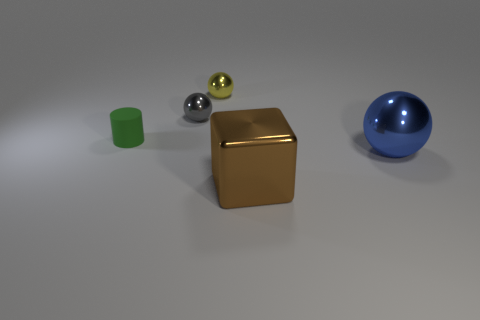What number of tiny cylinders are right of the rubber cylinder?
Provide a short and direct response. 0. There is a ball that is both in front of the yellow shiny thing and behind the blue metal sphere; what is it made of?
Ensure brevity in your answer.  Metal. What number of other blocks have the same size as the block?
Give a very brief answer. 0. There is a small object on the left side of the tiny gray ball that is on the left side of the large brown cube; what color is it?
Give a very brief answer. Green. Are any brown matte objects visible?
Your answer should be compact. No. Is the shape of the small gray metallic object the same as the tiny yellow metal thing?
Provide a succinct answer. Yes. What number of spheres are behind the large thing on the right side of the brown metal cube?
Your response must be concise. 2. How many balls are right of the tiny yellow thing and behind the cylinder?
Ensure brevity in your answer.  0. What number of things are large red cylinders or things that are on the right side of the small matte thing?
Your answer should be very brief. 4. What size is the brown thing that is the same material as the tiny yellow thing?
Your answer should be very brief. Large. 